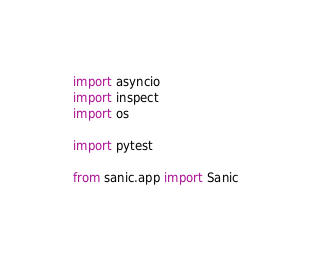Convert code to text. <code><loc_0><loc_0><loc_500><loc_500><_Python_>import asyncio
import inspect
import os

import pytest

from sanic.app import Sanic</code> 